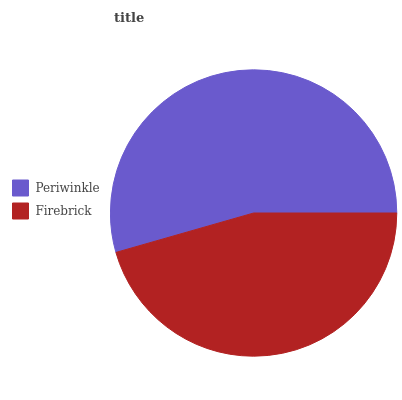Is Firebrick the minimum?
Answer yes or no. Yes. Is Periwinkle the maximum?
Answer yes or no. Yes. Is Firebrick the maximum?
Answer yes or no. No. Is Periwinkle greater than Firebrick?
Answer yes or no. Yes. Is Firebrick less than Periwinkle?
Answer yes or no. Yes. Is Firebrick greater than Periwinkle?
Answer yes or no. No. Is Periwinkle less than Firebrick?
Answer yes or no. No. Is Periwinkle the high median?
Answer yes or no. Yes. Is Firebrick the low median?
Answer yes or no. Yes. Is Firebrick the high median?
Answer yes or no. No. Is Periwinkle the low median?
Answer yes or no. No. 